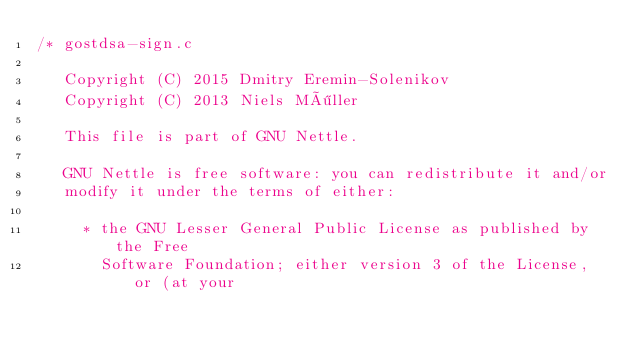Convert code to text. <code><loc_0><loc_0><loc_500><loc_500><_C_>/* gostdsa-sign.c

   Copyright (C) 2015 Dmitry Eremin-Solenikov
   Copyright (C) 2013 Niels Möller

   This file is part of GNU Nettle.

   GNU Nettle is free software: you can redistribute it and/or
   modify it under the terms of either:

     * the GNU Lesser General Public License as published by the Free
       Software Foundation; either version 3 of the License, or (at your</code> 